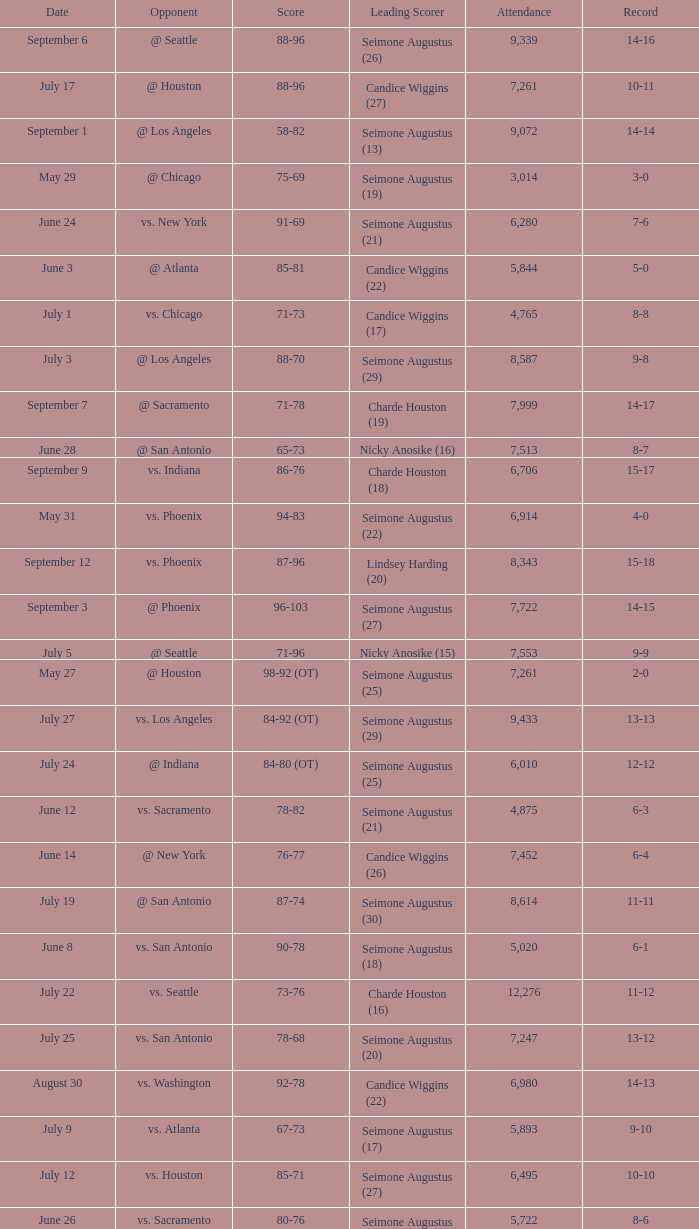Which Leading Scorer has an Opponent of @ seattle, and a Record of 14-16? Seimone Augustus (26). 